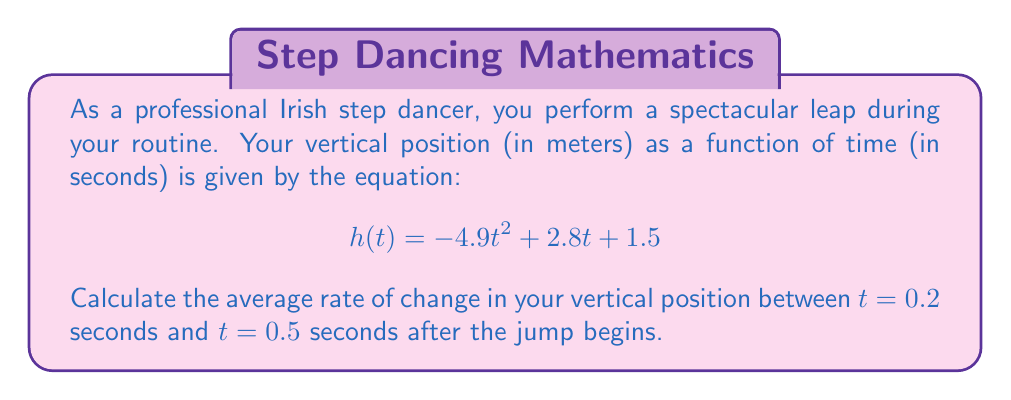Provide a solution to this math problem. To find the average rate of change in vertical position, we need to calculate the slope between two points on the function $h(t)$. The formula for the average rate of change is:

$$\text{Average rate of change} = \frac{h(t_2) - h(t_1)}{t_2 - t_1}$$

Where $t_1 = 0.2$ and $t_2 = 0.5$.

Let's calculate the vertical positions at these two times:

For $t = 0.2$:
$$\begin{align*}
h(0.2) &= -4.9(0.2)^2 + 2.8(0.2) + 1.5 \\
&= -4.9(0.04) + 0.56 + 1.5 \\
&= -0.196 + 0.56 + 1.5 \\
&= 1.864 \text{ meters}
\end{align*}$$

For $t = 0.5$:
$$\begin{align*}
h(0.5) &= -4.9(0.5)^2 + 2.8(0.5) + 1.5 \\
&= -4.9(0.25) + 1.4 + 1.5 \\
&= -1.225 + 1.4 + 1.5 \\
&= 1.675 \text{ meters}
\end{align*}$$

Now we can calculate the average rate of change:

$$\begin{align*}
\text{Average rate of change} &= \frac{h(0.5) - h(0.2)}{0.5 - 0.2} \\
&= \frac{1.675 - 1.864}{0.3} \\
&= \frac{-0.189}{0.3} \\
&= -0.63 \text{ meters per second}
\end{align*}$$
Answer: The average rate of change in vertical position between $t = 0.2$ seconds and $t = 0.5$ seconds is $-0.63$ meters per second. 